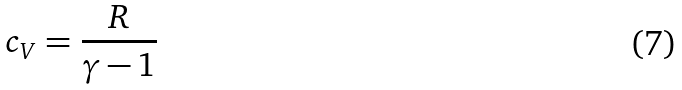Convert formula to latex. <formula><loc_0><loc_0><loc_500><loc_500>c _ { V } = \frac { R } { \gamma - 1 }</formula> 